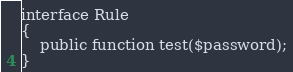Convert code to text. <code><loc_0><loc_0><loc_500><loc_500><_PHP_>
interface Rule
{
    public function test($password);
}</code> 